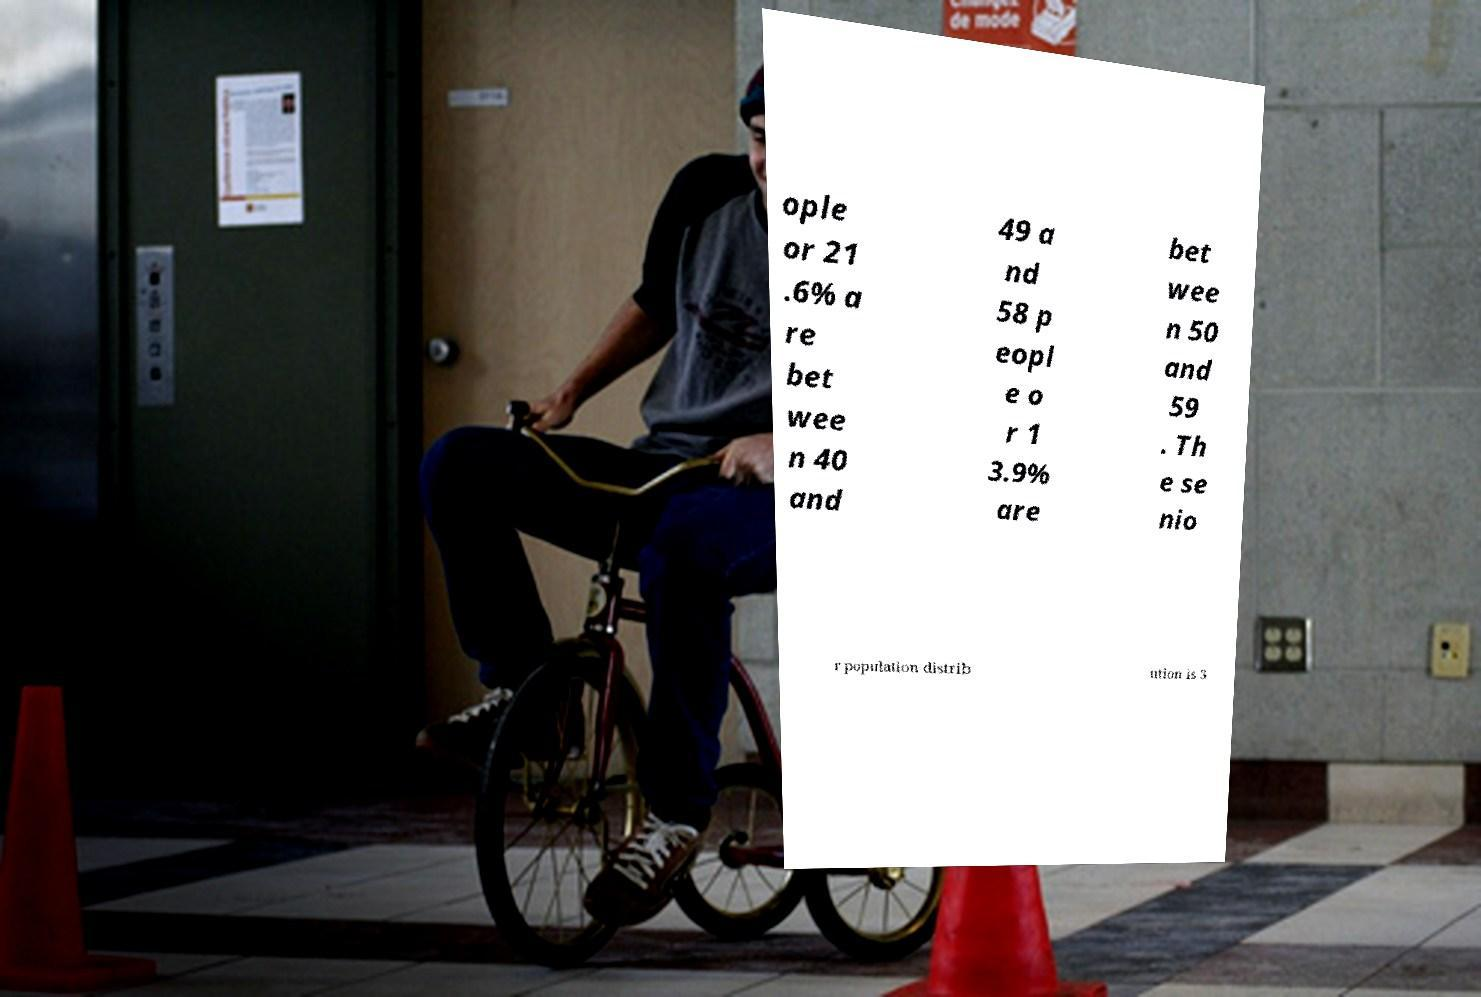Can you accurately transcribe the text from the provided image for me? ople or 21 .6% a re bet wee n 40 and 49 a nd 58 p eopl e o r 1 3.9% are bet wee n 50 and 59 . Th e se nio r population distrib ution is 3 